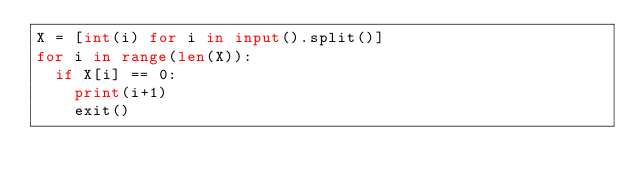Convert code to text. <code><loc_0><loc_0><loc_500><loc_500><_Python_>X = [int(i) for i in input().split()]
for i in range(len(X)):
  if X[i] == 0:
    print(i+1)
    exit()</code> 